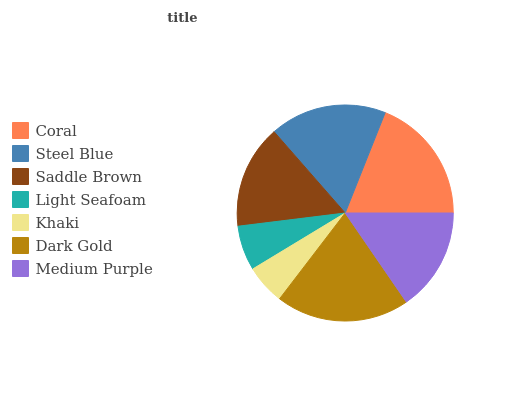Is Khaki the minimum?
Answer yes or no. Yes. Is Dark Gold the maximum?
Answer yes or no. Yes. Is Steel Blue the minimum?
Answer yes or no. No. Is Steel Blue the maximum?
Answer yes or no. No. Is Coral greater than Steel Blue?
Answer yes or no. Yes. Is Steel Blue less than Coral?
Answer yes or no. Yes. Is Steel Blue greater than Coral?
Answer yes or no. No. Is Coral less than Steel Blue?
Answer yes or no. No. Is Saddle Brown the high median?
Answer yes or no. Yes. Is Saddle Brown the low median?
Answer yes or no. Yes. Is Medium Purple the high median?
Answer yes or no. No. Is Medium Purple the low median?
Answer yes or no. No. 